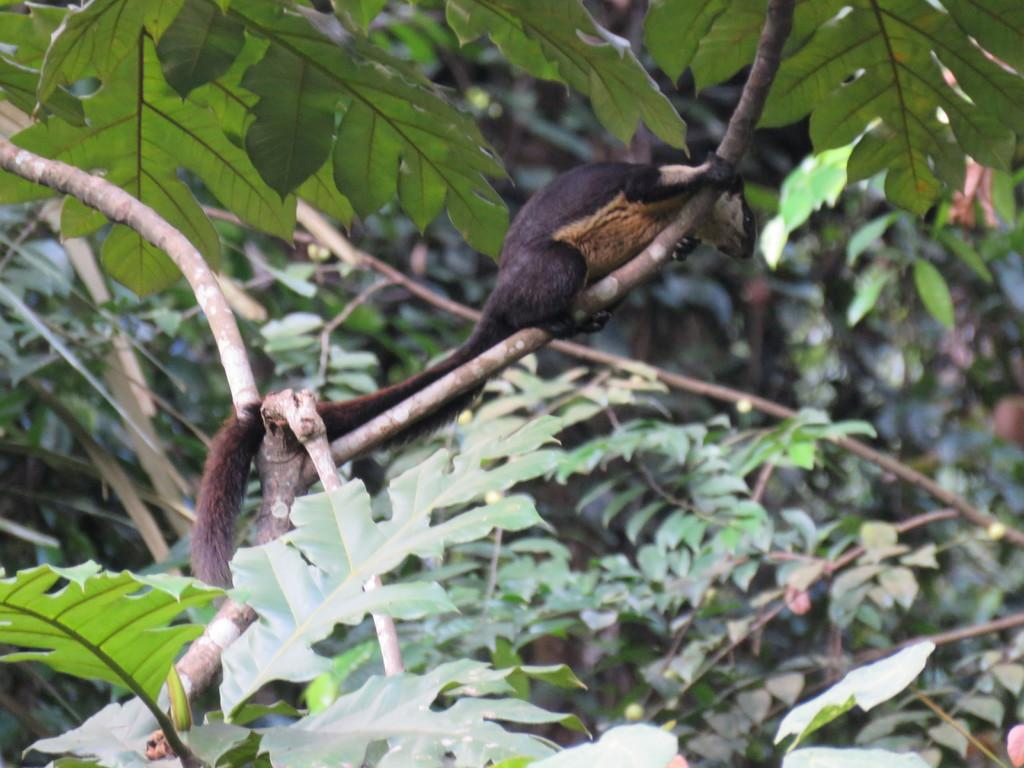What type of creature is in the image? There is an animal in the image. Where is the animal located? The animal is on a branch. What can be seen in the background of the image? There are leaves visible in the background of the image. What type of lead is the animal using to communicate with others in the image? There is no lead present in the image, and the animal is not communicating with others. 